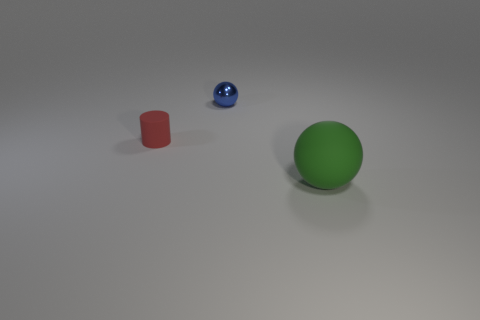Could you estimate the sizes of the objects? Based on the perspective, the green sphere appears to be the largest object, possibly around the size of a standard basketball. The red cylinder could be compared to the size of a soda can, and the blue sphere might be the size of a small marble. 